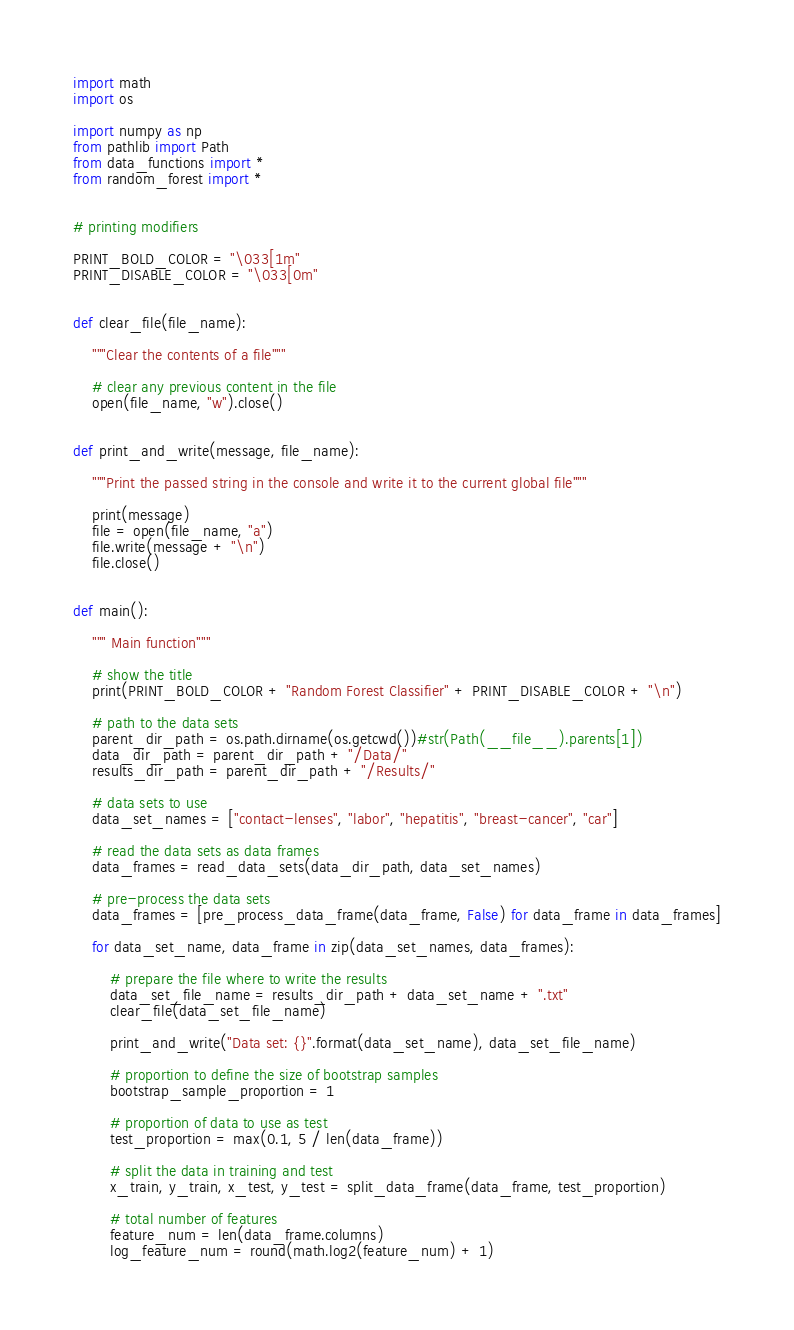<code> <loc_0><loc_0><loc_500><loc_500><_Python_>import math
import os

import numpy as np
from pathlib import Path
from data_functions import *
from random_forest import *


# printing modifiers

PRINT_BOLD_COLOR = "\033[1m"
PRINT_DISABLE_COLOR = "\033[0m"


def clear_file(file_name):

    """Clear the contents of a file"""

    # clear any previous content in the file
    open(file_name, "w").close()


def print_and_write(message, file_name):

    """Print the passed string in the console and write it to the current global file"""

    print(message)
    file = open(file_name, "a")
    file.write(message + "\n")
    file.close()


def main():

    """ Main function"""

    # show the title
    print(PRINT_BOLD_COLOR + "Random Forest Classifier" + PRINT_DISABLE_COLOR + "\n")

    # path to the data sets
    parent_dir_path = os.path.dirname(os.getcwd())#str(Path(__file__).parents[1])
    data_dir_path = parent_dir_path + "/Data/"
    results_dir_path = parent_dir_path + "/Results/"

    # data sets to use
    data_set_names = ["contact-lenses", "labor", "hepatitis", "breast-cancer", "car"]

    # read the data sets as data frames
    data_frames = read_data_sets(data_dir_path, data_set_names)

    # pre-process the data sets
    data_frames = [pre_process_data_frame(data_frame, False) for data_frame in data_frames]

    for data_set_name, data_frame in zip(data_set_names, data_frames):

        # prepare the file where to write the results
        data_set_file_name = results_dir_path + data_set_name + ".txt"
        clear_file(data_set_file_name)

        print_and_write("Data set: {}".format(data_set_name), data_set_file_name)

        # proportion to define the size of bootstrap samples
        bootstrap_sample_proportion = 1

        # proportion of data to use as test
        test_proportion = max(0.1, 5 / len(data_frame))

        # split the data in training and test
        x_train, y_train, x_test, y_test = split_data_frame(data_frame, test_proportion)

        # total number of features
        feature_num = len(data_frame.columns)
        log_feature_num = round(math.log2(feature_num) + 1)</code> 